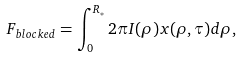<formula> <loc_0><loc_0><loc_500><loc_500>F _ { b l o c k e d } = \int _ { 0 } ^ { R _ { * } } 2 \pi I ( \rho ) x ( \rho , \tau ) d \rho ,</formula> 